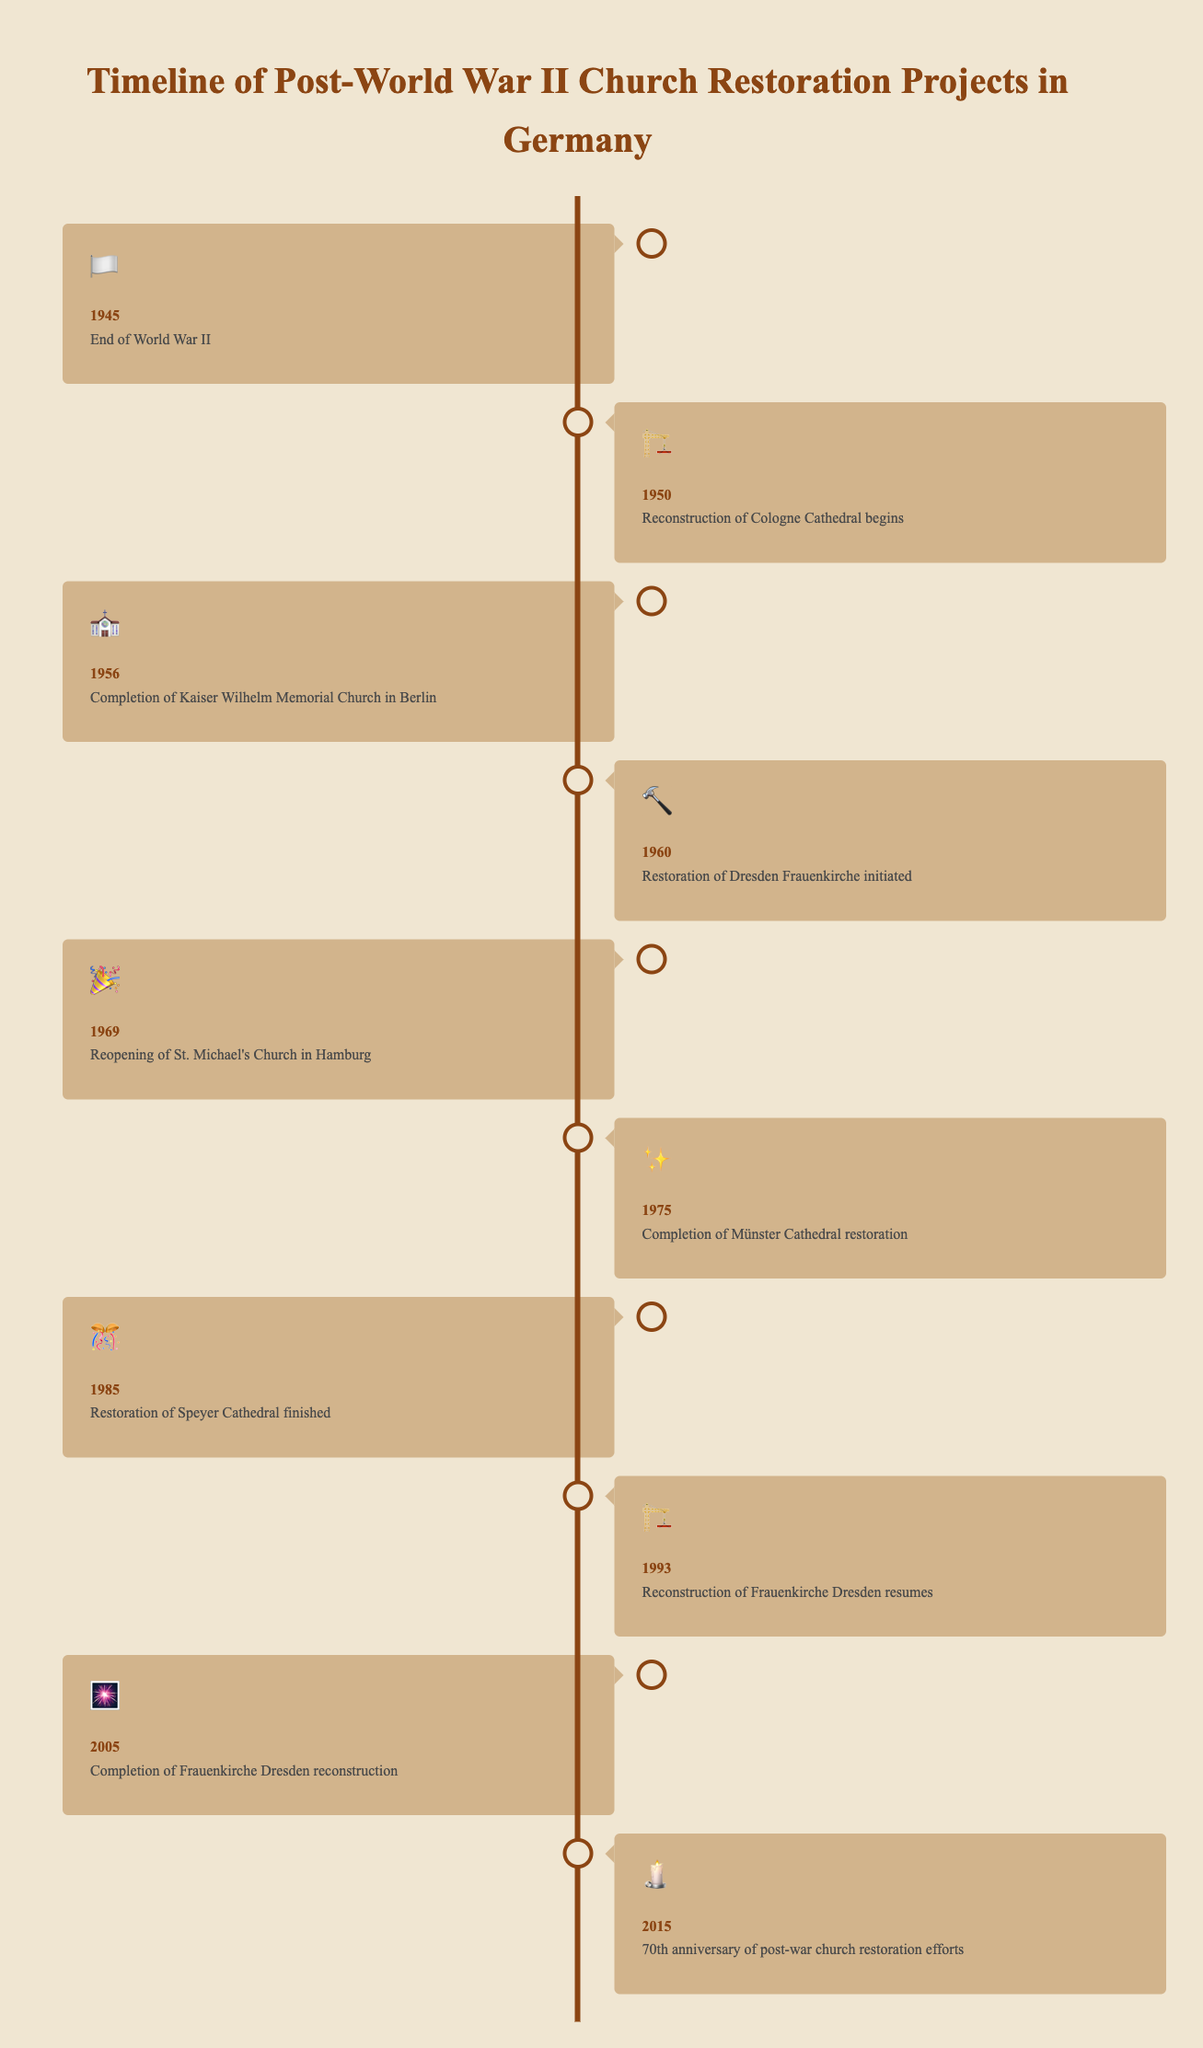When does the timeline of the post-World War II church restoration projects in Germany begin? The timeline begins with the end of World War II. This is indicated by the milestone for the year 1945.
Answer: 1945 Which event in the timeline is marked with the emoji "🎆"? The emoji "🎆" indicates the completion of the Frauenkirche Dresden reconstruction, which is in the year 2005.
Answer: 2005 How many years after the end of World War II did the reconstruction of Cologne Cathedral begin? The end of World War II was in 1945, and the reconstruction of Cologne Cathedral began in 1950. The difference between these years is 1950 - 1945 = 5 years.
Answer: 5 years What is the next event in the timeline after the restoration of Dresden Frauenkirche was initiated in 1960? The next event after the Dresden Frauenkirche restoration initiation in 1960 is the reopening of St. Michael's Church in Hamburg in 1969.
Answer: Reopening of St. Michael's Church in 1969 Comparing the completion of the Kaiser Wilhelm Memorial Church and the start of the Frauenkirche Dresden reconstruction, which event happened first? The Kaiser Wilhelm Memorial Church was completed in 1956, while the restoration of Frauenkirche Dresden started in 1960. Therefore, the completion of the Kaiser Wilhelm Memorial Church happened first.
Answer: Completion of Kaiser Wilhelm Memorial Church What is the total number of church restoration events listed between 1945 and 2005? The events listed between 1945 (end of World War II) and 2005 (completion of Frauenkirche Dresden reconstruction) include seven restoration events.
Answer: 7 events Which event is illustrated by the "🏗️" emoji first? The "🏗️" emoji first appears in 1950 for the reconstruction of Cologne Cathedral.
Answer: Reconstruction of Cologne Cathedral in 1950 How much time elapsed between the reopening of St. Michael's Church in Hamburg and the completion of Münster Cathedral restoration? St. Michael's Church in Hamburg reopened in 1969, and the Münster Cathedral restoration was completed in 1975. The time elapsed between these events is 1975 - 1969 = 6 years.
Answer: 6 years What does the "🕯️" emoji signify in the timeline? The "🕯️" emoji signifies the 70th anniversary of post-war church restoration efforts in 2015.
Answer: 70th anniversary in 2015 